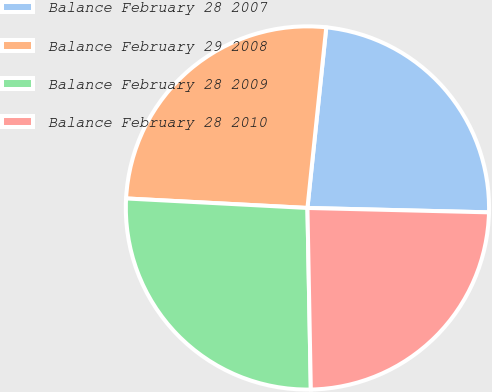Convert chart to OTSL. <chart><loc_0><loc_0><loc_500><loc_500><pie_chart><fcel>Balance February 28 2007<fcel>Balance February 29 2008<fcel>Balance February 28 2009<fcel>Balance February 28 2010<nl><fcel>23.73%<fcel>25.82%<fcel>26.13%<fcel>24.32%<nl></chart> 